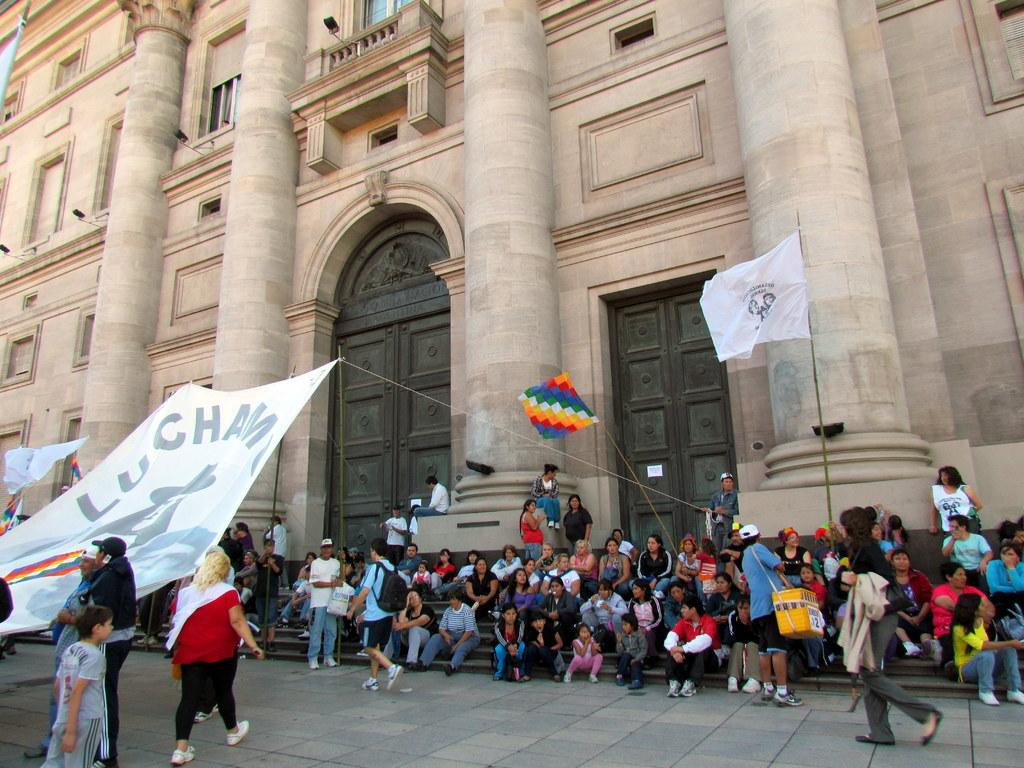What are the people in the image doing? There are many people sitting on steps, and some people are walking. What can be seen in the image that represents a symbol or country? There are flags in the image. What is hanging in the image that might have a message or announcement? There is a banner in the image. What type of structure is visible in the background of the image? There is a building with doors and pillars in the background. What type of alley can be seen in the image? There is no alley present in the image. What type of shade is provided by the building in the image? The image does not show any specific shade provided by the building; it only shows the building's doors and pillars. 